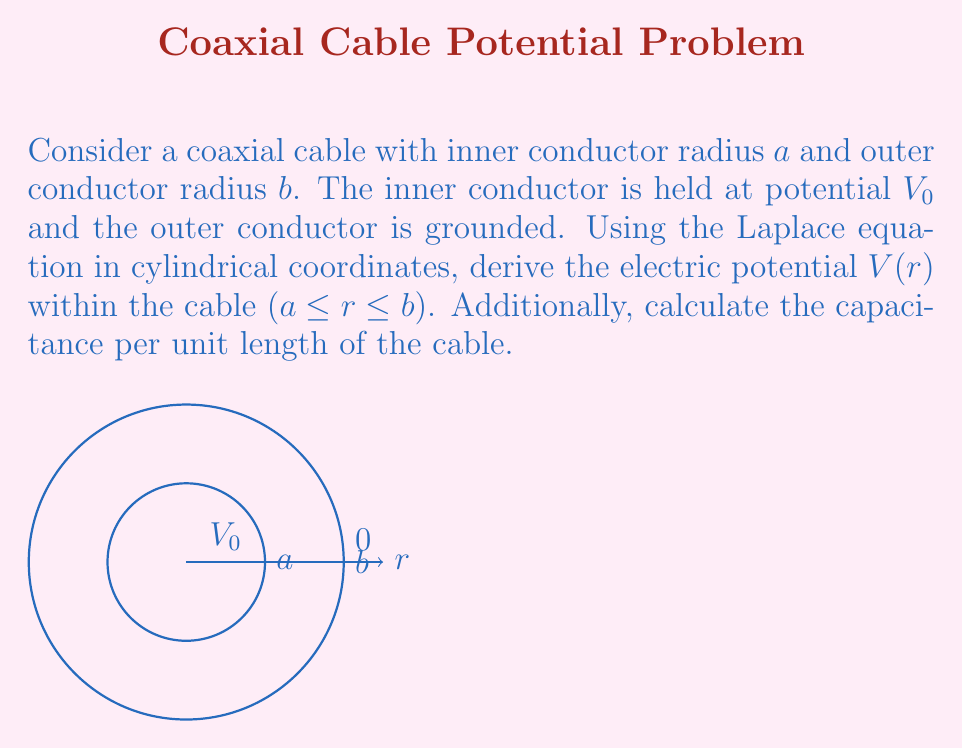What is the answer to this math problem? 1) The Laplace equation in cylindrical coordinates for a system with azimuthal symmetry and no z-dependence is:

   $$\frac{1}{r}\frac{d}{dr}\left(r\frac{dV}{dr}\right) = 0$$

2) Multiply both sides by $r$:

   $$\frac{d}{dr}\left(r\frac{dV}{dr}\right) = 0$$

3) Integrate both sides with respect to $r$:

   $$r\frac{dV}{dr} = C_1$$

   where $C_1$ is a constant of integration.

4) Divide both sides by $r$ and integrate again:

   $$V(r) = C_1 \ln(r) + C_2$$

   where $C_2$ is another constant of integration.

5) Apply the boundary conditions:
   At $r = a$, $V(a) = V_0$
   At $r = b$, $V(b) = 0$

6) Solve for $C_1$ and $C_2$:

   $$V_0 = C_1 \ln(a) + C_2$$
   $$0 = C_1 \ln(b) + C_2$$

   Subtracting these equations:

   $$V_0 = C_1 (\ln(a) - \ln(b)) = C_1 \ln(a/b)$$

   $$C_1 = \frac{V_0}{\ln(a/b)}$$

   $$C_2 = -\frac{V_0 \ln(b)}{\ln(a/b)}$$

7) The final expression for $V(r)$ is:

   $$V(r) = \frac{V_0}{\ln(a/b)} \ln(r/b)$$

8) To find the capacitance per unit length, we use $C = Q/V_0$ where $Q$ is the charge per unit length. We can find $Q$ using Gauss's law:

   $$Q = -2\pi\epsilon_0 r \left.\frac{dV}{dr}\right|_{r=a} = \frac{2\pi\epsilon_0 V_0}{\ln(b/a)}$$

9) Therefore, the capacitance per unit length is:

   $$C = \frac{Q}{V_0} = \frac{2\pi\epsilon_0}{\ln(b/a)}$$
Answer: $V(r) = \frac{V_0}{\ln(a/b)} \ln(r/b)$, $C = \frac{2\pi\epsilon_0}{\ln(b/a)}$ 